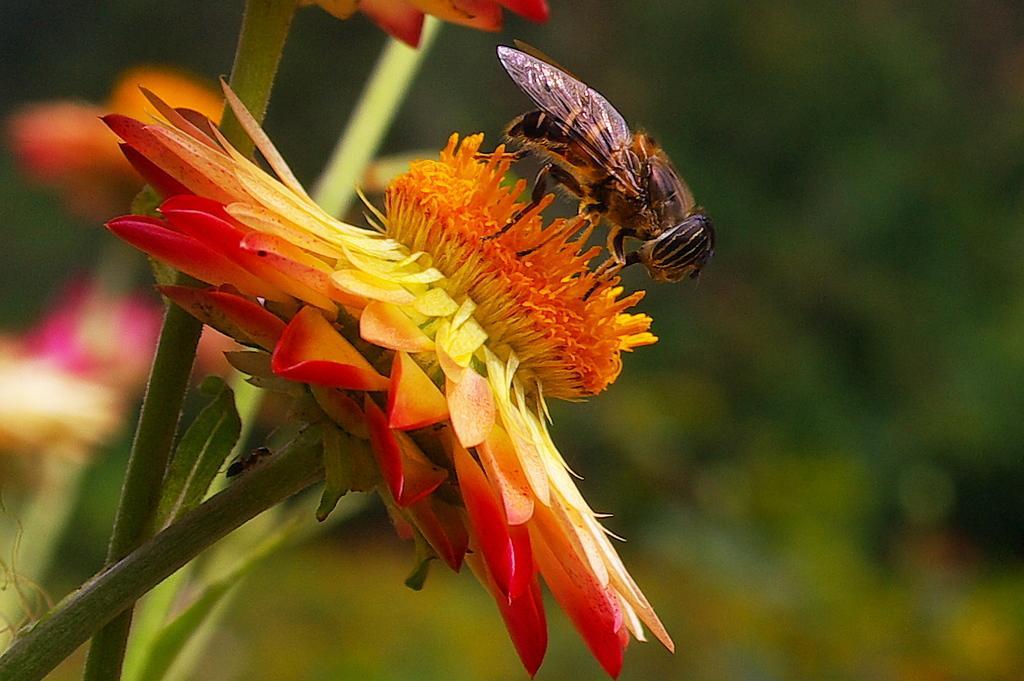How would you summarize this image in a sentence or two? This image consists of a flower. On that there is one insect. That flower is in orange color. 